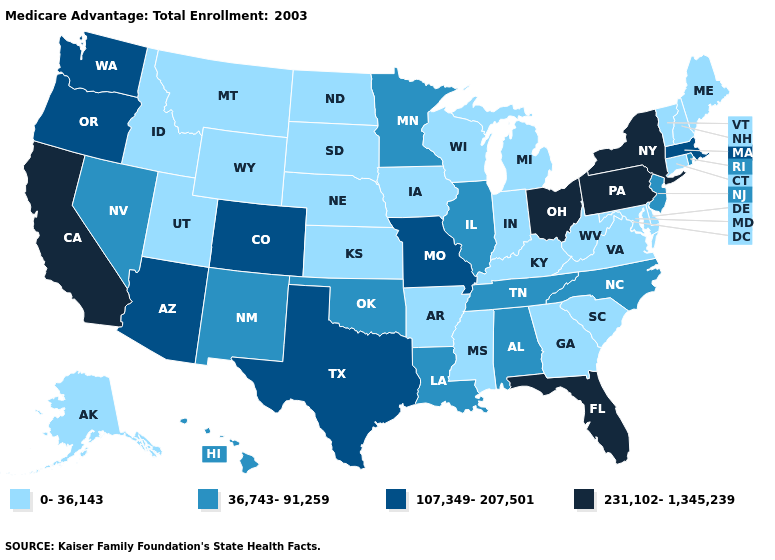Does Connecticut have the highest value in the Northeast?
Keep it brief. No. Does New Jersey have the lowest value in the USA?
Concise answer only. No. What is the value of Missouri?
Be succinct. 107,349-207,501. What is the value of New Hampshire?
Be succinct. 0-36,143. Which states have the lowest value in the Northeast?
Write a very short answer. Connecticut, Maine, New Hampshire, Vermont. Among the states that border Connecticut , does Massachusetts have the highest value?
Be succinct. No. What is the highest value in the Northeast ?
Write a very short answer. 231,102-1,345,239. What is the highest value in states that border Georgia?
Be succinct. 231,102-1,345,239. What is the lowest value in the MidWest?
Give a very brief answer. 0-36,143. What is the highest value in the USA?
Give a very brief answer. 231,102-1,345,239. What is the highest value in the Northeast ?
Keep it brief. 231,102-1,345,239. What is the lowest value in the USA?
Keep it brief. 0-36,143. Name the states that have a value in the range 0-36,143?
Be succinct. Alaska, Arkansas, Connecticut, Delaware, Georgia, Iowa, Idaho, Indiana, Kansas, Kentucky, Maryland, Maine, Michigan, Mississippi, Montana, North Dakota, Nebraska, New Hampshire, South Carolina, South Dakota, Utah, Virginia, Vermont, Wisconsin, West Virginia, Wyoming. How many symbols are there in the legend?
Write a very short answer. 4. Which states have the lowest value in the South?
Concise answer only. Arkansas, Delaware, Georgia, Kentucky, Maryland, Mississippi, South Carolina, Virginia, West Virginia. 